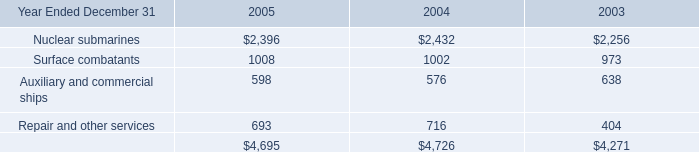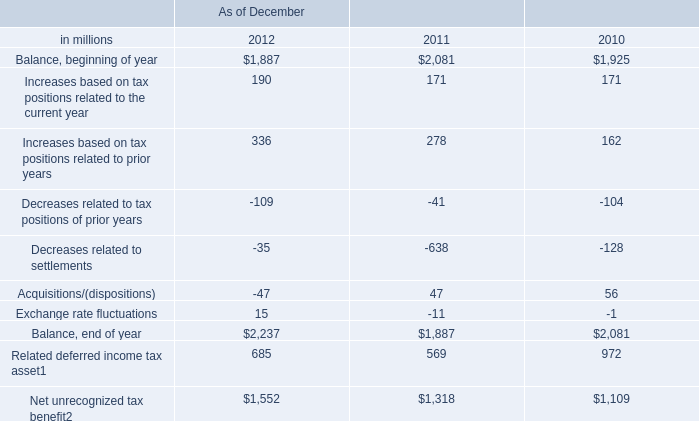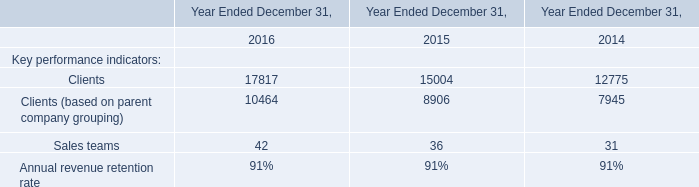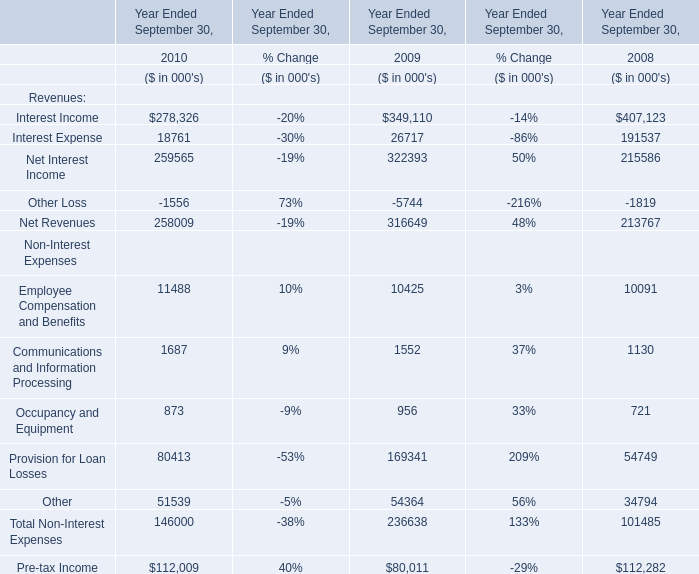What is the average amount of Nuclear submarines of 2003, and Clients of Year Ended December 31, 2014 ? 
Computations: ((2256.0 + 12775.0) / 2)
Answer: 7515.5. what's the total amount of Clients of Year Ended December 31, 2016, Balance, beginning of year of As of December 2010, and Clients of Year Ended December 31, 2014 ? 
Computations: ((17817.0 + 1925.0) + 12775.0)
Answer: 32517.0. 